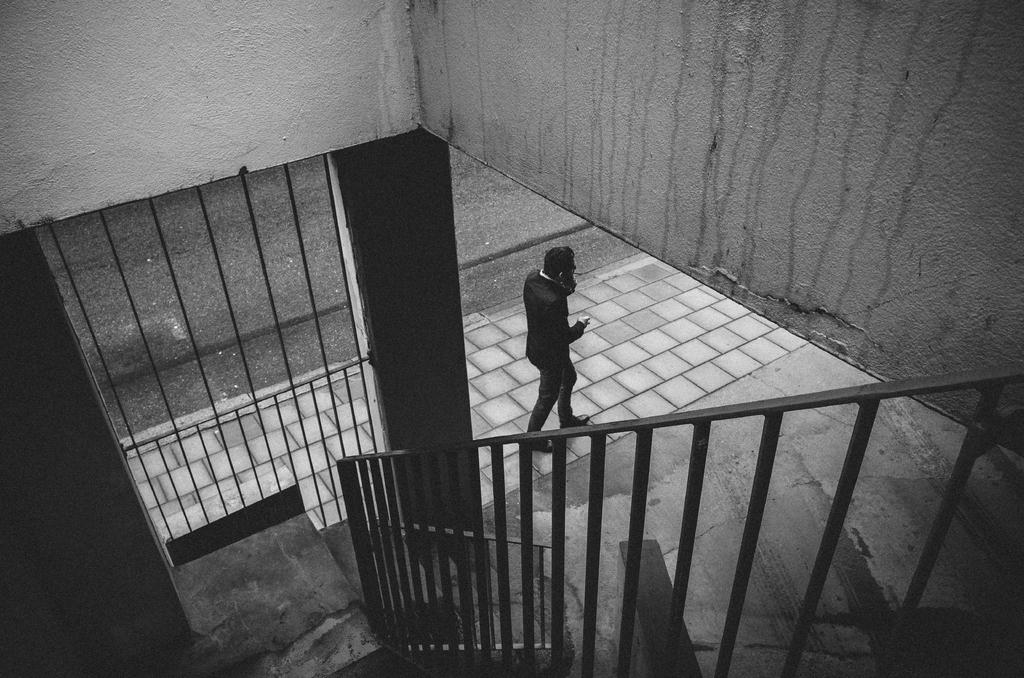What can be seen in the foreground of the image? In the foreground of the image, there is railing and stairs. What is located at the top of the image? There is a wall at the top of the image. What is happening in the background of the image? In the background, there is a man walking on the pavement. Can you see any honey dripping from the railing in the image? No, there is no honey present in the image. Are there any vegetables growing on the wall in the image? No, there are no vegetables visible in the image. 